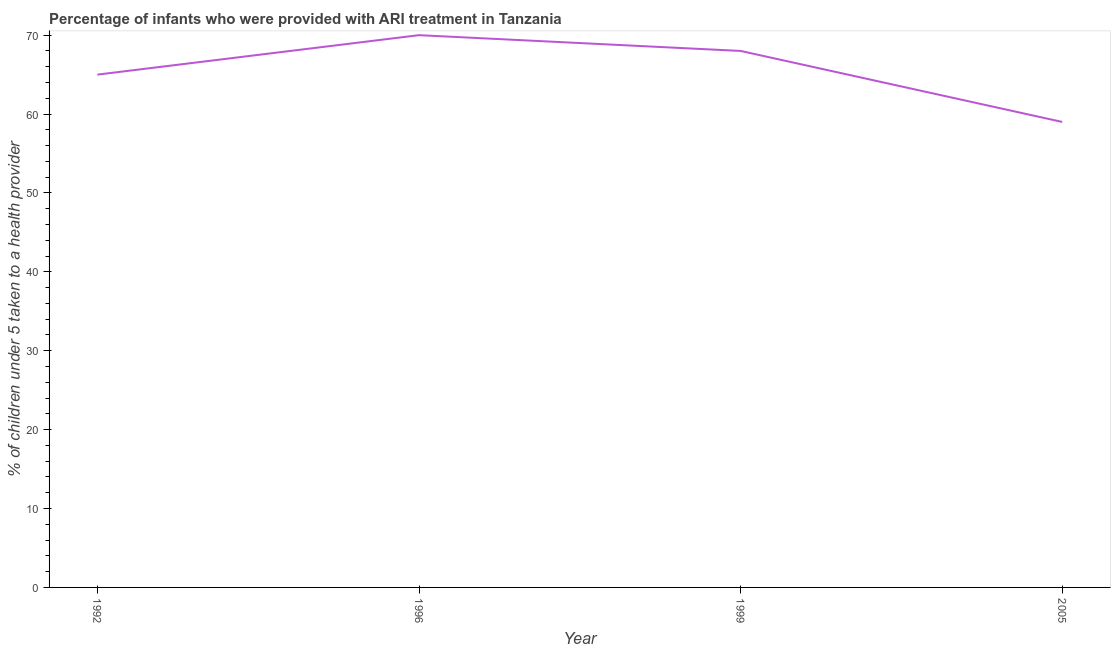What is the percentage of children who were provided with ari treatment in 1996?
Give a very brief answer. 70. In which year was the percentage of children who were provided with ari treatment maximum?
Provide a succinct answer. 1996. In which year was the percentage of children who were provided with ari treatment minimum?
Provide a succinct answer. 2005. What is the sum of the percentage of children who were provided with ari treatment?
Your answer should be very brief. 262. What is the average percentage of children who were provided with ari treatment per year?
Your answer should be very brief. 65.5. What is the median percentage of children who were provided with ari treatment?
Ensure brevity in your answer.  66.5. In how many years, is the percentage of children who were provided with ari treatment greater than 16 %?
Ensure brevity in your answer.  4. What is the ratio of the percentage of children who were provided with ari treatment in 1996 to that in 1999?
Provide a succinct answer. 1.03. Is the difference between the percentage of children who were provided with ari treatment in 1996 and 2005 greater than the difference between any two years?
Offer a terse response. Yes. What is the difference between the highest and the second highest percentage of children who were provided with ari treatment?
Provide a succinct answer. 2. What is the difference between the highest and the lowest percentage of children who were provided with ari treatment?
Offer a terse response. 11. In how many years, is the percentage of children who were provided with ari treatment greater than the average percentage of children who were provided with ari treatment taken over all years?
Ensure brevity in your answer.  2. Does the percentage of children who were provided with ari treatment monotonically increase over the years?
Offer a terse response. No. What is the difference between two consecutive major ticks on the Y-axis?
Your response must be concise. 10. Does the graph contain any zero values?
Offer a terse response. No. What is the title of the graph?
Your response must be concise. Percentage of infants who were provided with ARI treatment in Tanzania. What is the label or title of the X-axis?
Make the answer very short. Year. What is the label or title of the Y-axis?
Give a very brief answer. % of children under 5 taken to a health provider. What is the % of children under 5 taken to a health provider of 1992?
Your response must be concise. 65. What is the % of children under 5 taken to a health provider of 1996?
Ensure brevity in your answer.  70. What is the difference between the % of children under 5 taken to a health provider in 1992 and 1996?
Provide a short and direct response. -5. What is the difference between the % of children under 5 taken to a health provider in 1992 and 1999?
Your answer should be very brief. -3. What is the difference between the % of children under 5 taken to a health provider in 1996 and 2005?
Ensure brevity in your answer.  11. What is the difference between the % of children under 5 taken to a health provider in 1999 and 2005?
Offer a terse response. 9. What is the ratio of the % of children under 5 taken to a health provider in 1992 to that in 1996?
Ensure brevity in your answer.  0.93. What is the ratio of the % of children under 5 taken to a health provider in 1992 to that in 1999?
Offer a terse response. 0.96. What is the ratio of the % of children under 5 taken to a health provider in 1992 to that in 2005?
Your answer should be compact. 1.1. What is the ratio of the % of children under 5 taken to a health provider in 1996 to that in 1999?
Give a very brief answer. 1.03. What is the ratio of the % of children under 5 taken to a health provider in 1996 to that in 2005?
Ensure brevity in your answer.  1.19. What is the ratio of the % of children under 5 taken to a health provider in 1999 to that in 2005?
Your answer should be very brief. 1.15. 